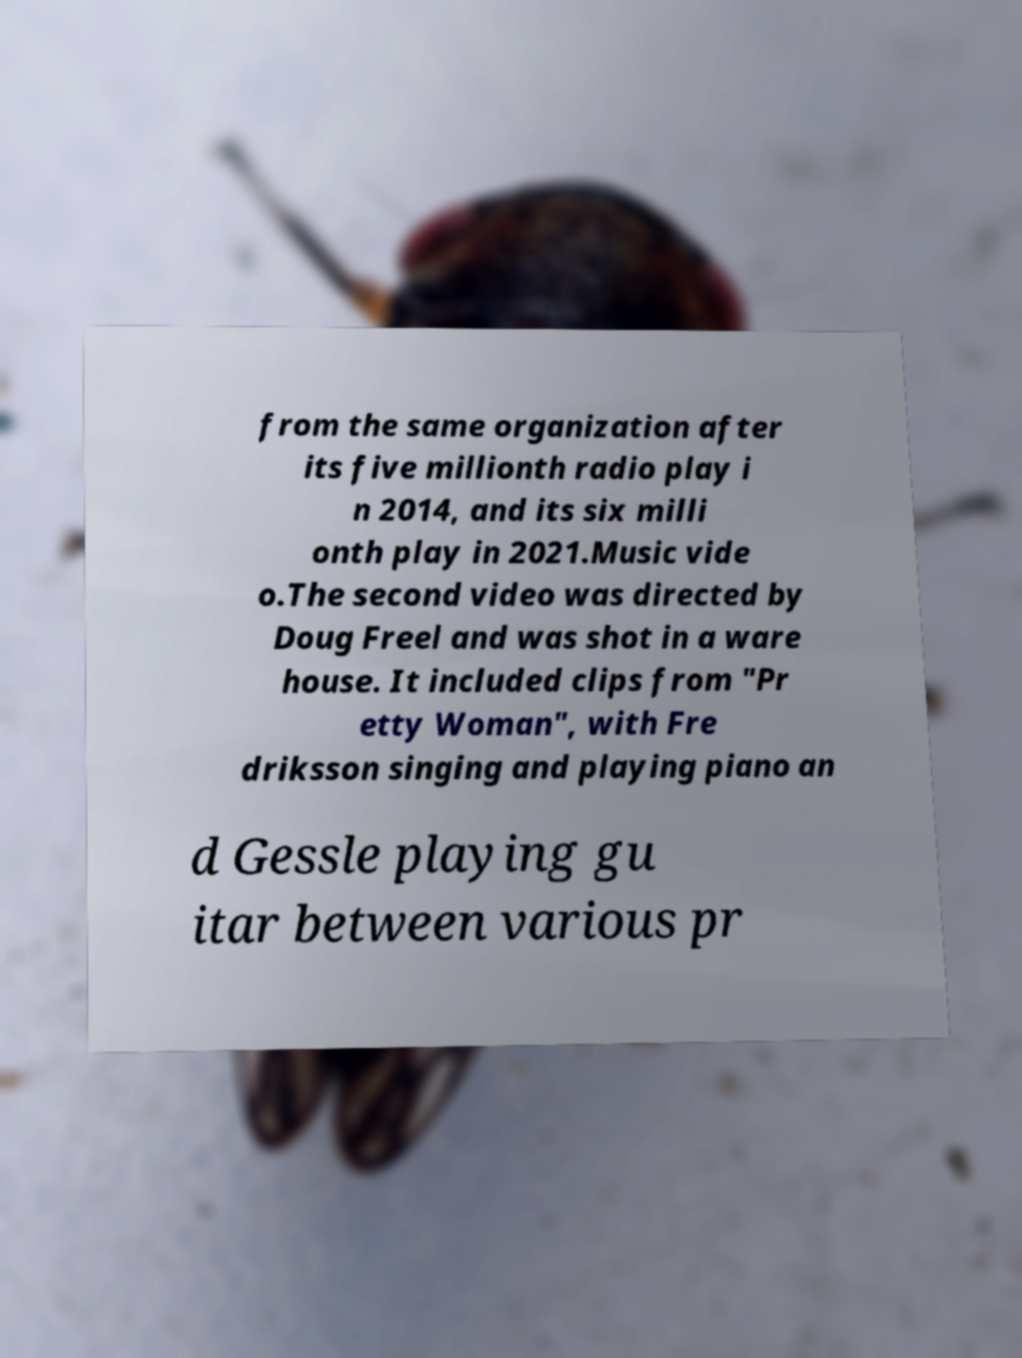What messages or text are displayed in this image? I need them in a readable, typed format. from the same organization after its five millionth radio play i n 2014, and its six milli onth play in 2021.Music vide o.The second video was directed by Doug Freel and was shot in a ware house. It included clips from "Pr etty Woman", with Fre driksson singing and playing piano an d Gessle playing gu itar between various pr 